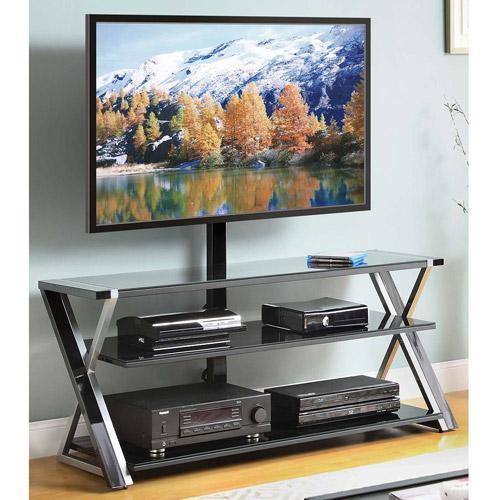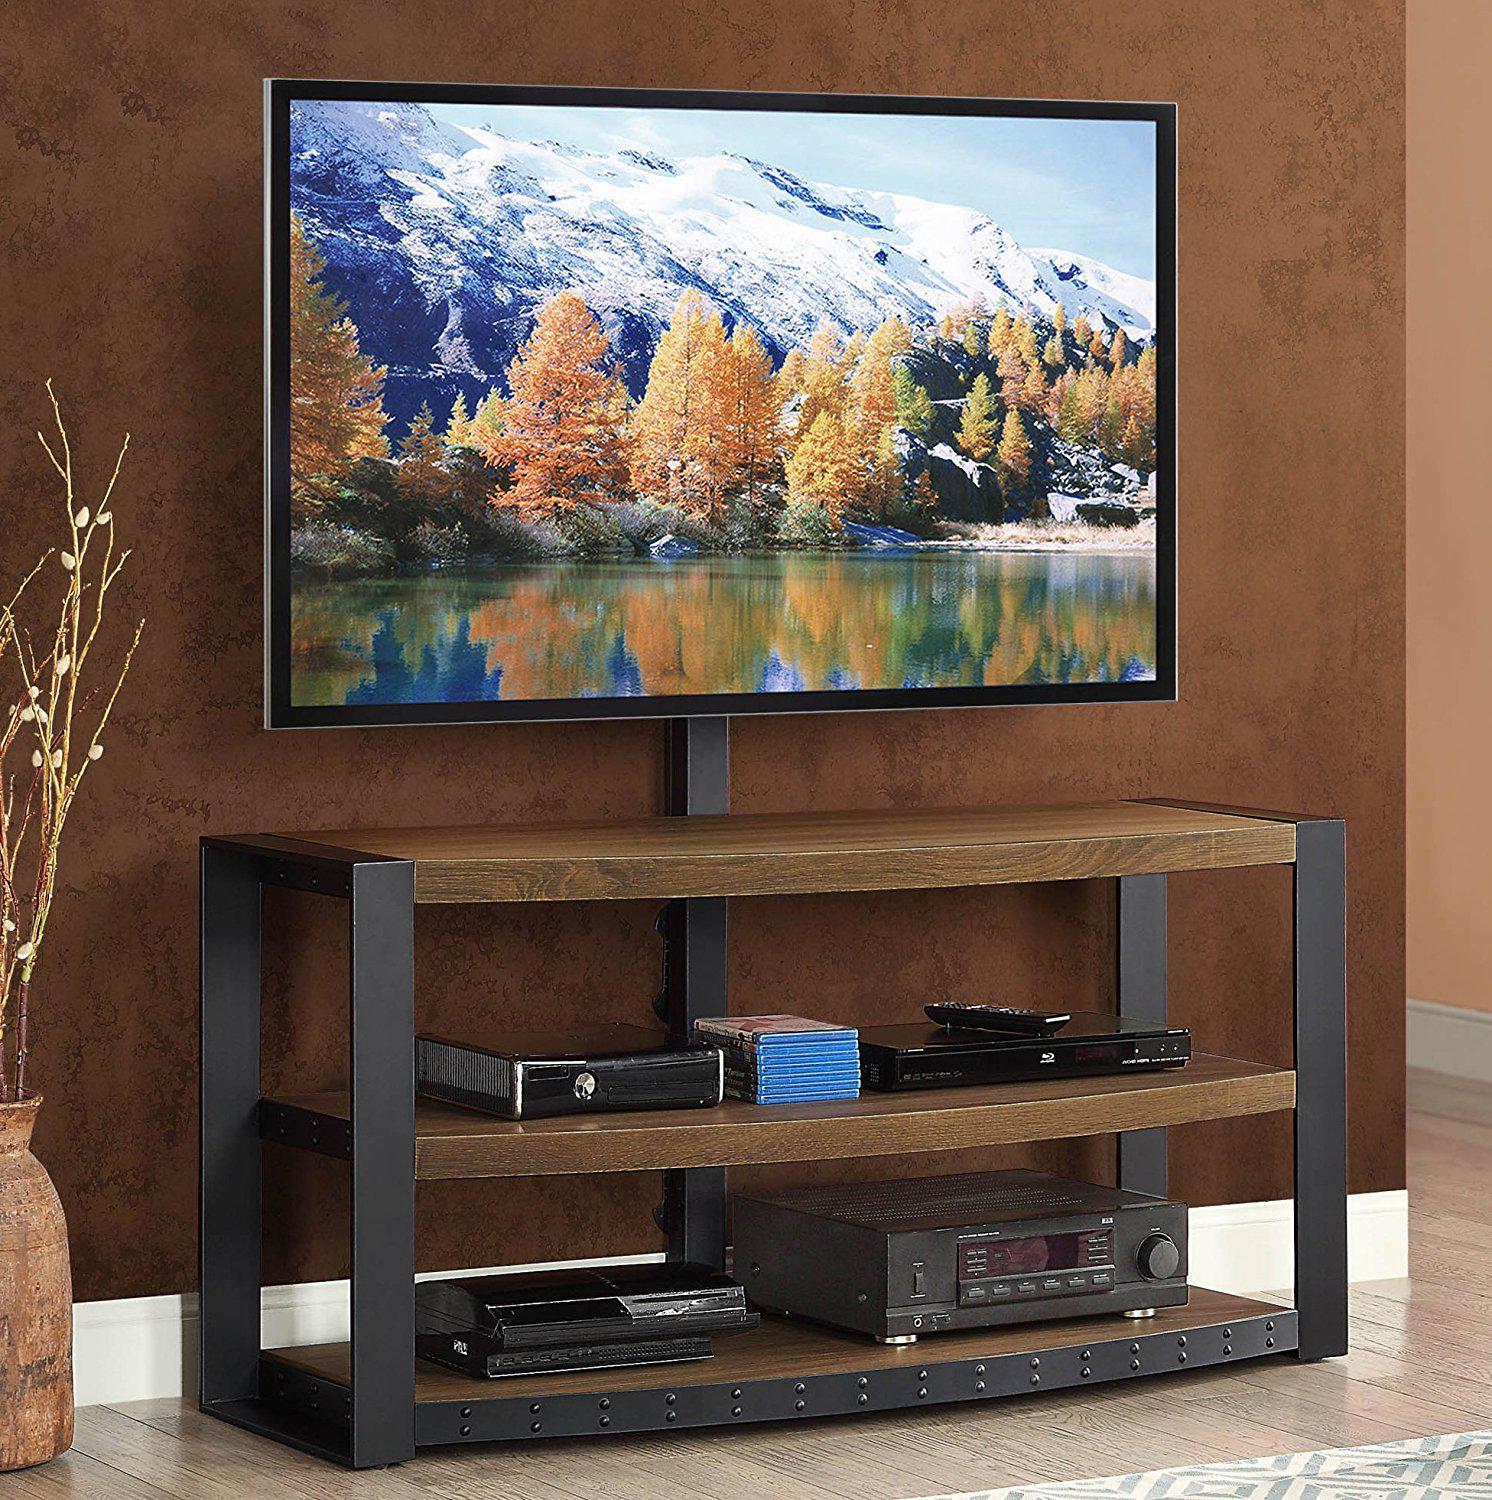The first image is the image on the left, the second image is the image on the right. Examine the images to the left and right. Is the description "Left and right images each feature a TV stand with a curved piece on each end, but do not have the same picture playing on the TV." accurate? Answer yes or no. No. 